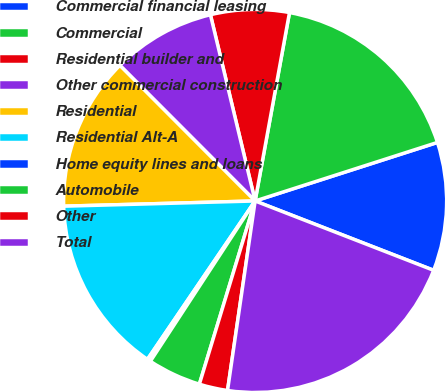Convert chart to OTSL. <chart><loc_0><loc_0><loc_500><loc_500><pie_chart><fcel>Commercial financial leasing<fcel>Commercial<fcel>Residential builder and<fcel>Other commercial construction<fcel>Residential<fcel>Residential Alt-A<fcel>Home equity lines and loans<fcel>Automobile<fcel>Other<fcel>Total<nl><fcel>10.84%<fcel>17.18%<fcel>6.62%<fcel>8.73%<fcel>12.95%<fcel>15.06%<fcel>0.29%<fcel>4.51%<fcel>2.4%<fcel>21.4%<nl></chart> 